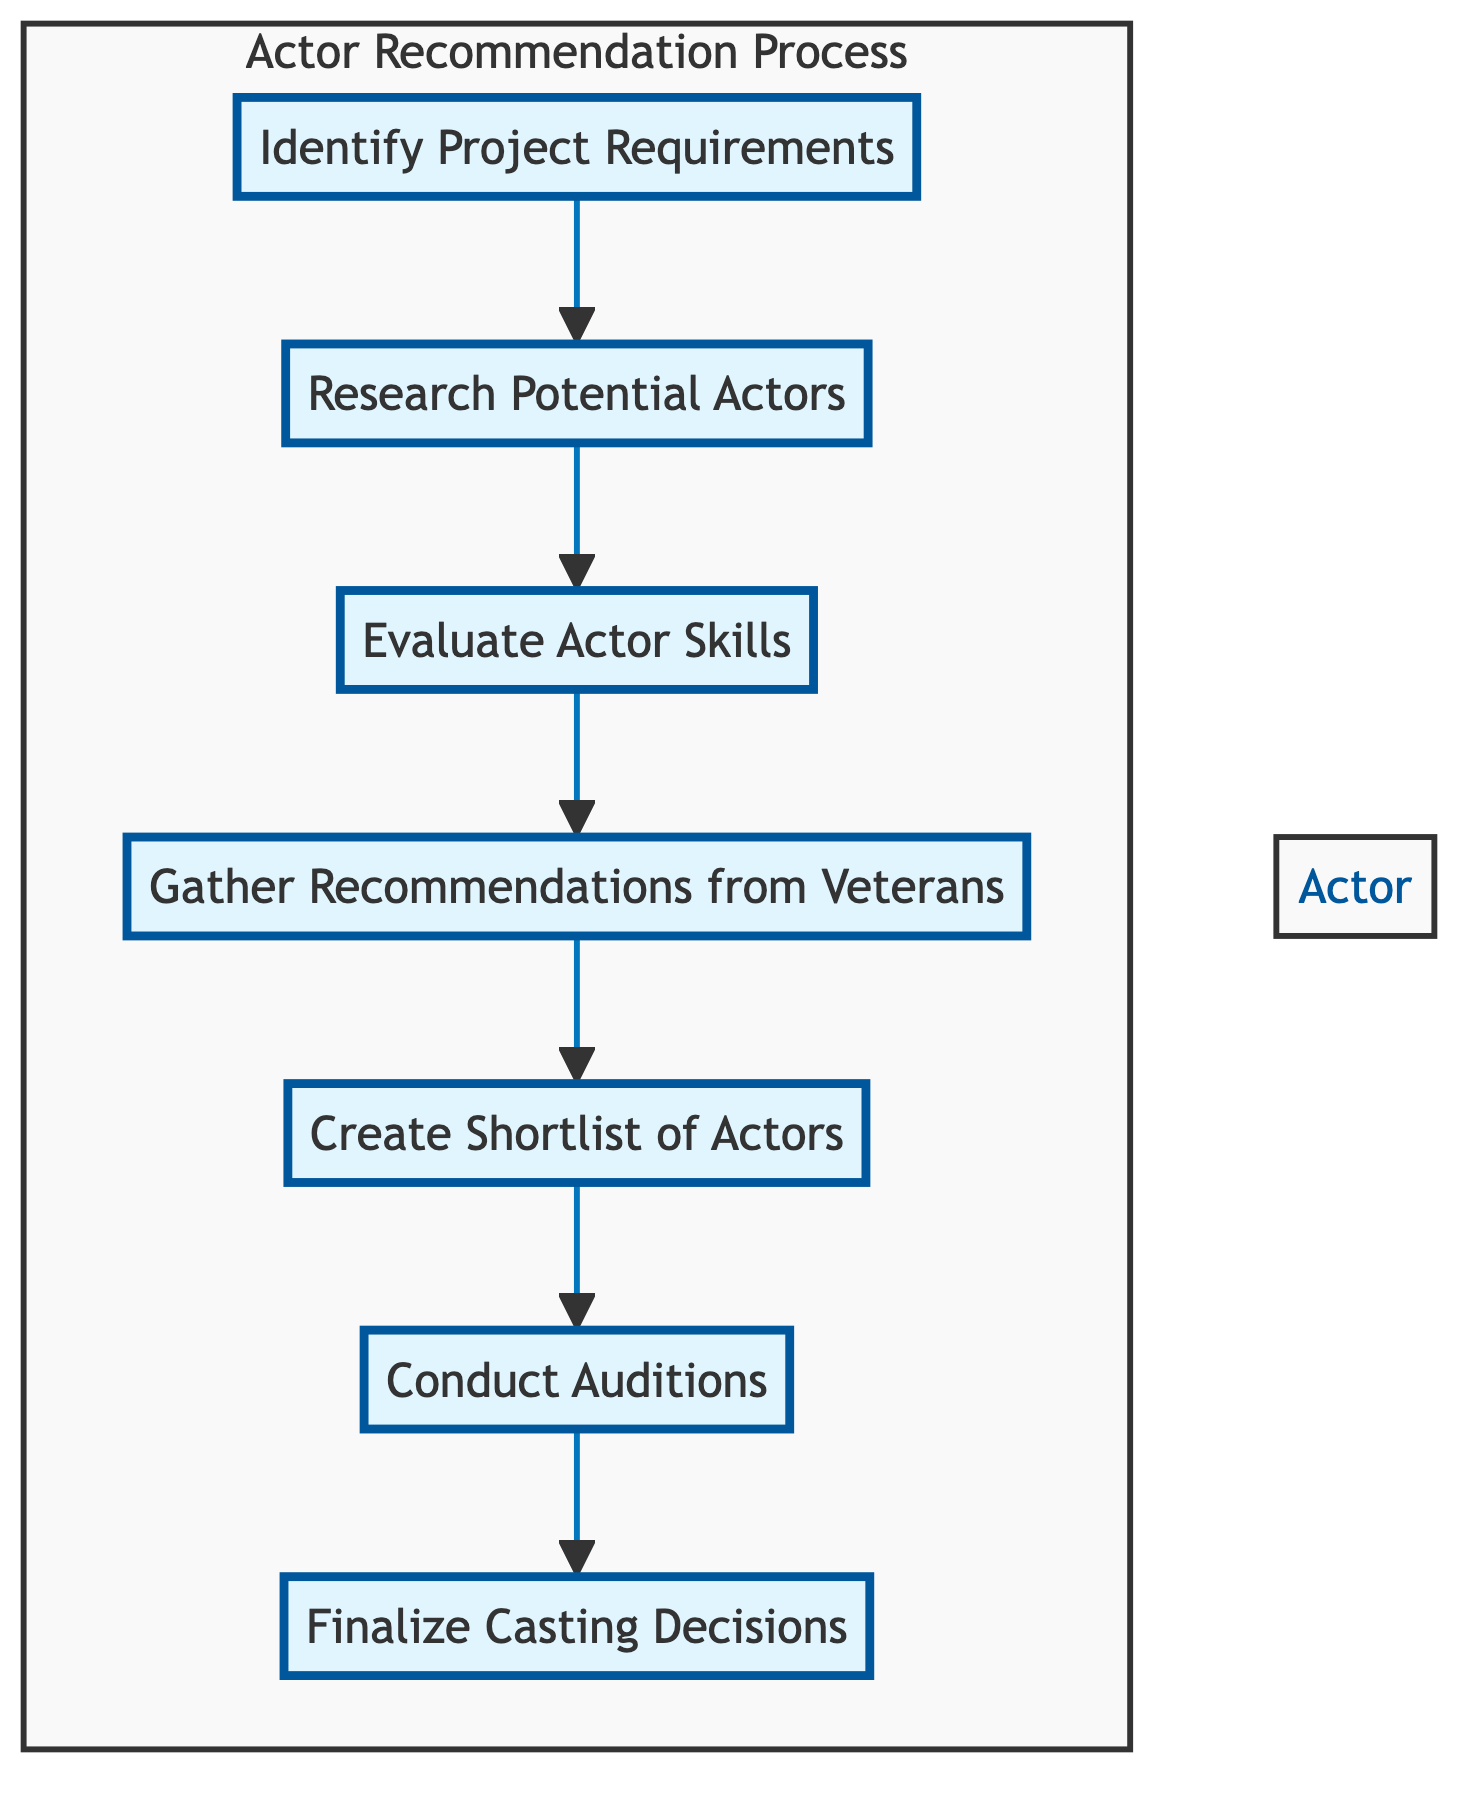What is the first step in the Actor Recommendation Process? The diagram shows that the first step is "Identify Project Requirements," which initiates the flow of the recommendation process.
Answer: Identify Project Requirements How many main steps are in the diagram? There are seven main steps outlined in the diagram, as each node represents a step in the actor recommendation process.
Answer: Seven What step follows after "Gather Recommendations from Veterans"? According to the diagram, the step that follows "Gather Recommendations from Veterans" is "Create Shortlist of Actors." This shows the progression of the process.
Answer: Create Shortlist of Actors What is the last step in the Actor Recommendation Process? The diagram indicates that the final step is "Finalize Casting Decisions," which concludes the entire process of recommending and selecting actors.
Answer: Finalize Casting Decisions Which step requires input from experienced actors? The step labeled "Gather Recommendations from Veterans" specifically denotes the action of seeking insights from experienced actors, highlighting its importance in the evaluation.
Answer: Gather Recommendations from Veterans How many connections lead out of the "Evaluate Actor Skills" step? "Evaluate Actor Skills" has only one connection leading out to "Gather Recommendations from Veterans," indicating a single progression from this evaluation step to the next action.
Answer: One Which two steps are directly connected without intermediate nodes? The steps "Conduct Auditions" and "Finalize Casting Decisions" are directly connected, showing a seamless transition from evaluating actors in action to making final decisions about casting.
Answer: Conduct Auditions and Finalize Casting Decisions What role does "Create Shortlist of Actors" play in the process? This step acts as a consolidating phase, narrowing down the pool of candidates after evaluations and recommendations, ensuring that only the most suitable actors advance to auditions.
Answer: Narrowing down candidates Which step involves assessing emotional depth? "Evaluate Actor Skills" encompasses assessing emotional depth, making it a crucial part of the overall evaluation of an actor's capabilities.
Answer: Evaluate Actor Skills 